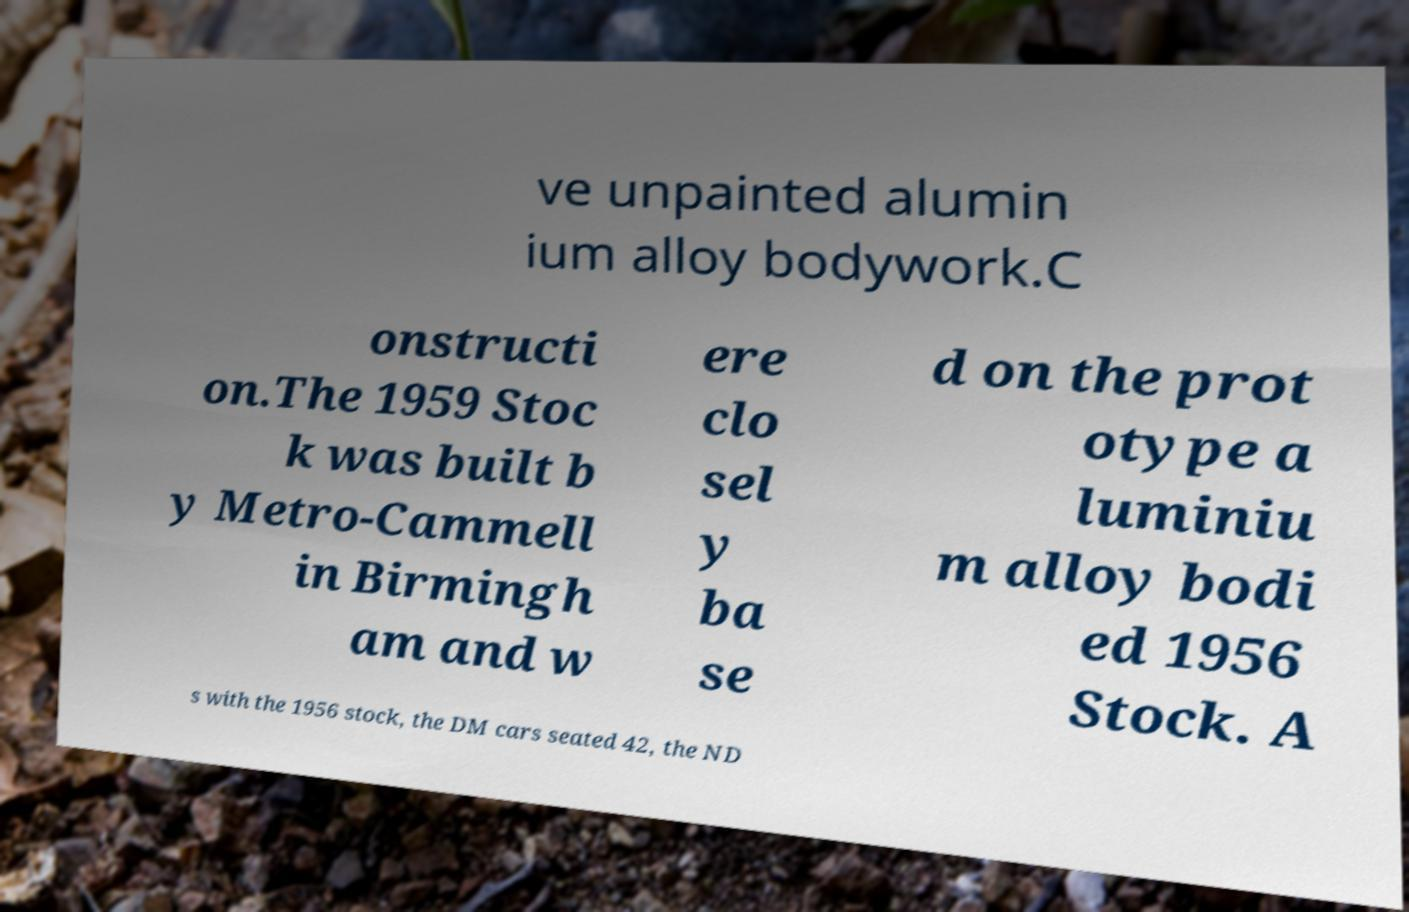Can you read and provide the text displayed in the image?This photo seems to have some interesting text. Can you extract and type it out for me? ve unpainted alumin ium alloy bodywork.C onstructi on.The 1959 Stoc k was built b y Metro-Cammell in Birmingh am and w ere clo sel y ba se d on the prot otype a luminiu m alloy bodi ed 1956 Stock. A s with the 1956 stock, the DM cars seated 42, the ND 